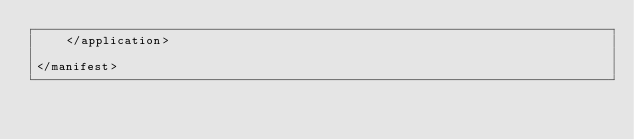Convert code to text. <code><loc_0><loc_0><loc_500><loc_500><_XML_>    </application>

</manifest>
</code> 